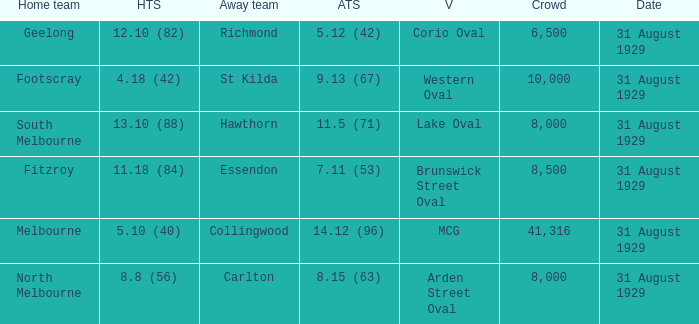What is the score of the away team when the crowd was larger than 8,000? 9.13 (67), 7.11 (53), 14.12 (96). 